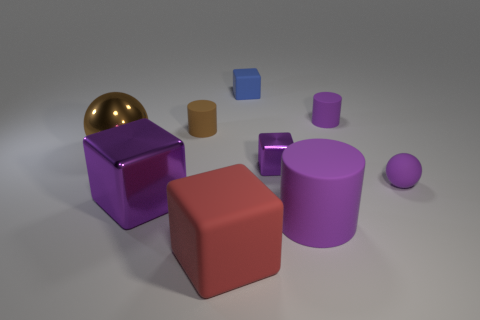Subtract all blue blocks. How many blocks are left? 3 Subtract all red balls. How many purple cylinders are left? 2 Add 1 big purple objects. How many objects exist? 10 Subtract all spheres. How many objects are left? 7 Subtract all red blocks. How many blocks are left? 3 Subtract 3 blocks. How many blocks are left? 1 Add 5 matte cubes. How many matte cubes exist? 7 Subtract 1 brown cylinders. How many objects are left? 8 Subtract all green cubes. Subtract all purple spheres. How many cubes are left? 4 Subtract all large red rubber things. Subtract all rubber cubes. How many objects are left? 6 